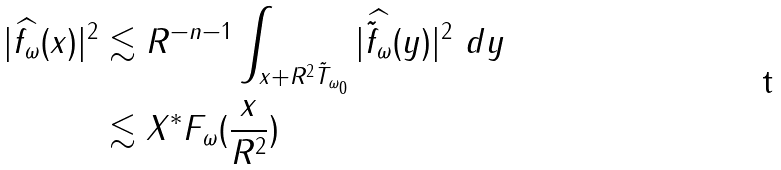<formula> <loc_0><loc_0><loc_500><loc_500>| \widehat { f _ { \omega } } ( x ) | ^ { 2 } & \lesssim R ^ { - n - 1 } \int _ { x + R ^ { 2 } \tilde { T } _ { \omega _ { 0 } } } | \widehat { \tilde { f } _ { \omega } } ( y ) | ^ { 2 } \ d y \\ & \lesssim X ^ { * } F _ { \omega } ( \frac { x } { R ^ { 2 } } )</formula> 